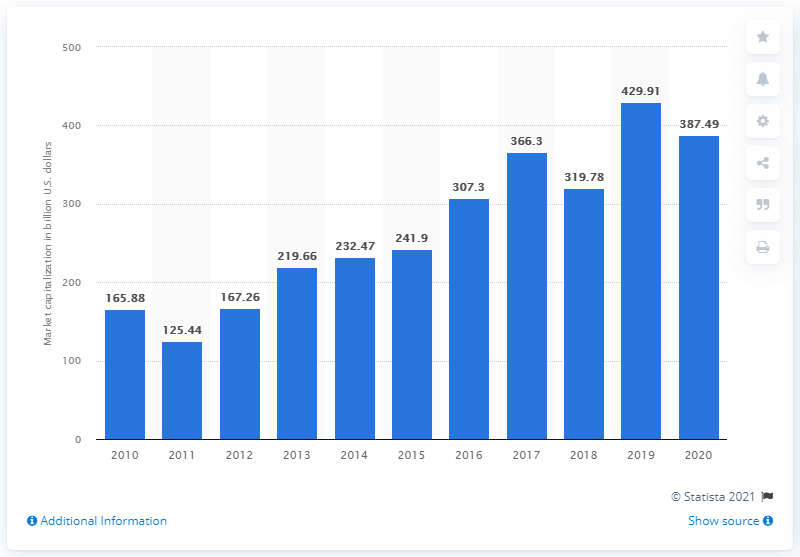Specify some key components in this picture. JPMorgan Chase had a market capitalization of approximately 387.49 billion dollars in 2020. In 2010, JPMorgan Chase's market capitalization was 167.26 billion dollars. 